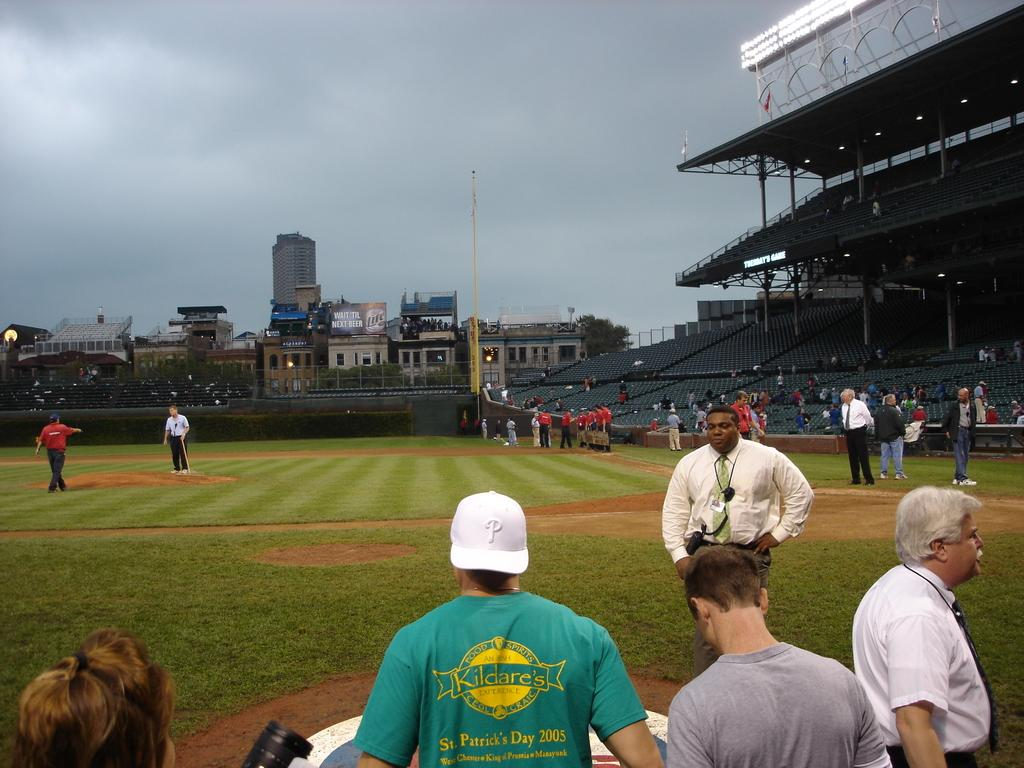<image>
Offer a succinct explanation of the picture presented. A man in a stadium wears a green t-shirt with a Kildare's logo. 